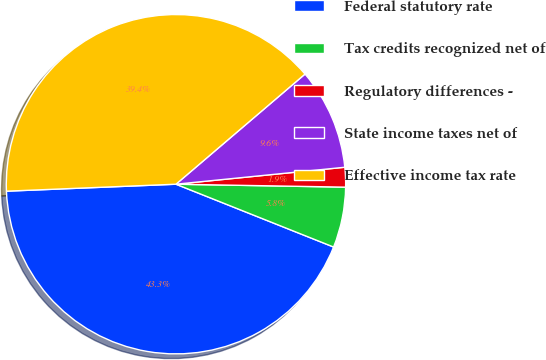<chart> <loc_0><loc_0><loc_500><loc_500><pie_chart><fcel>Federal statutory rate<fcel>Tax credits recognized net of<fcel>Regulatory differences -<fcel>State income taxes net of<fcel>Effective income tax rate<nl><fcel>43.31%<fcel>5.76%<fcel>1.87%<fcel>9.65%<fcel>39.41%<nl></chart> 